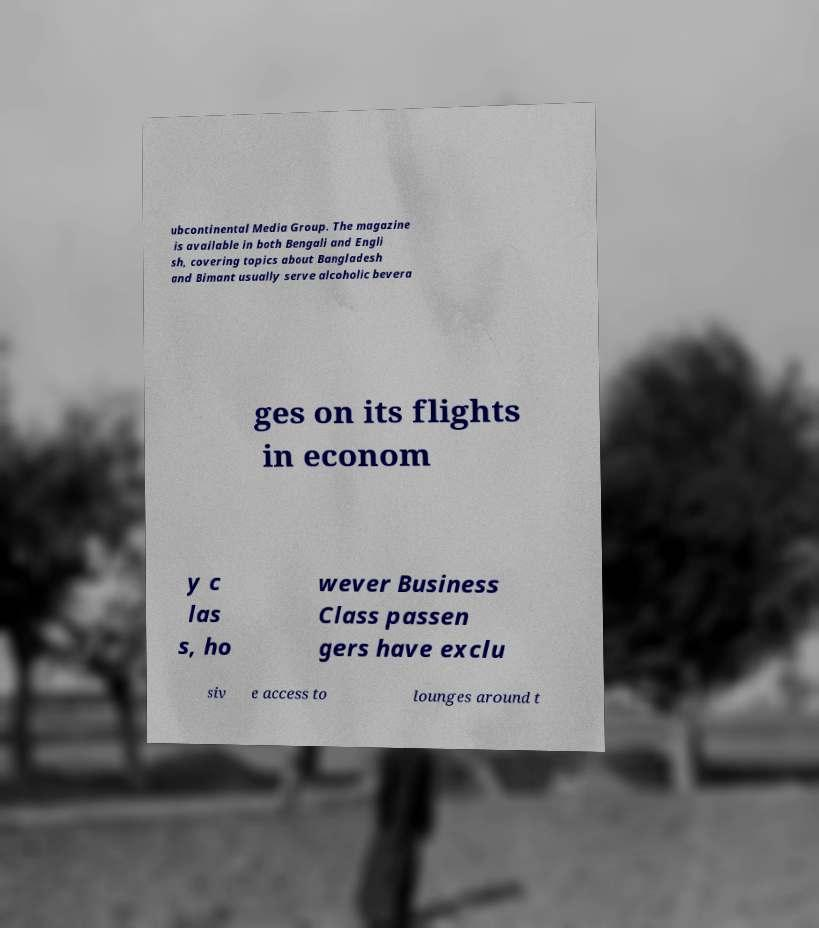Could you assist in decoding the text presented in this image and type it out clearly? ubcontinental Media Group. The magazine is available in both Bengali and Engli sh, covering topics about Bangladesh and Bimant usually serve alcoholic bevera ges on its flights in econom y c las s, ho wever Business Class passen gers have exclu siv e access to lounges around t 